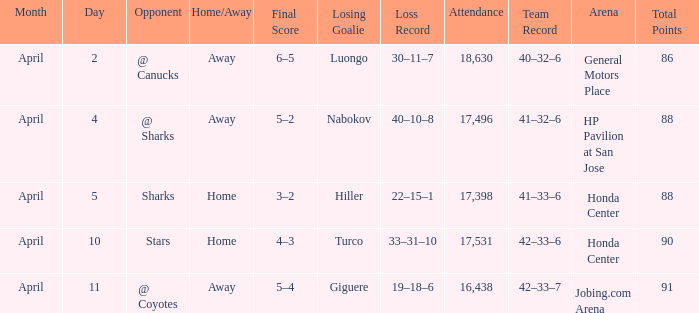Which score has a Loss of hiller (22–15–1)? 3–2. 